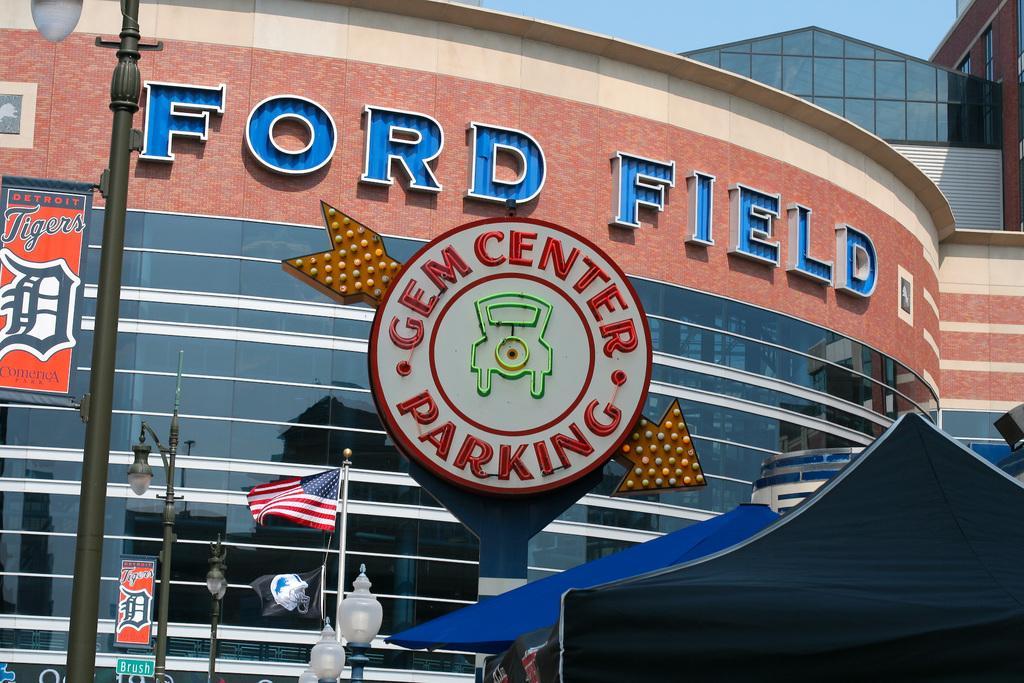How would you summarize this image in a sentence or two? In this image I can see few buildings. At the bottom there is a blue color tint and also I can see few light poles. There are few letter blocks attached to the wall of a building. At the top of the image I can see the sky. 